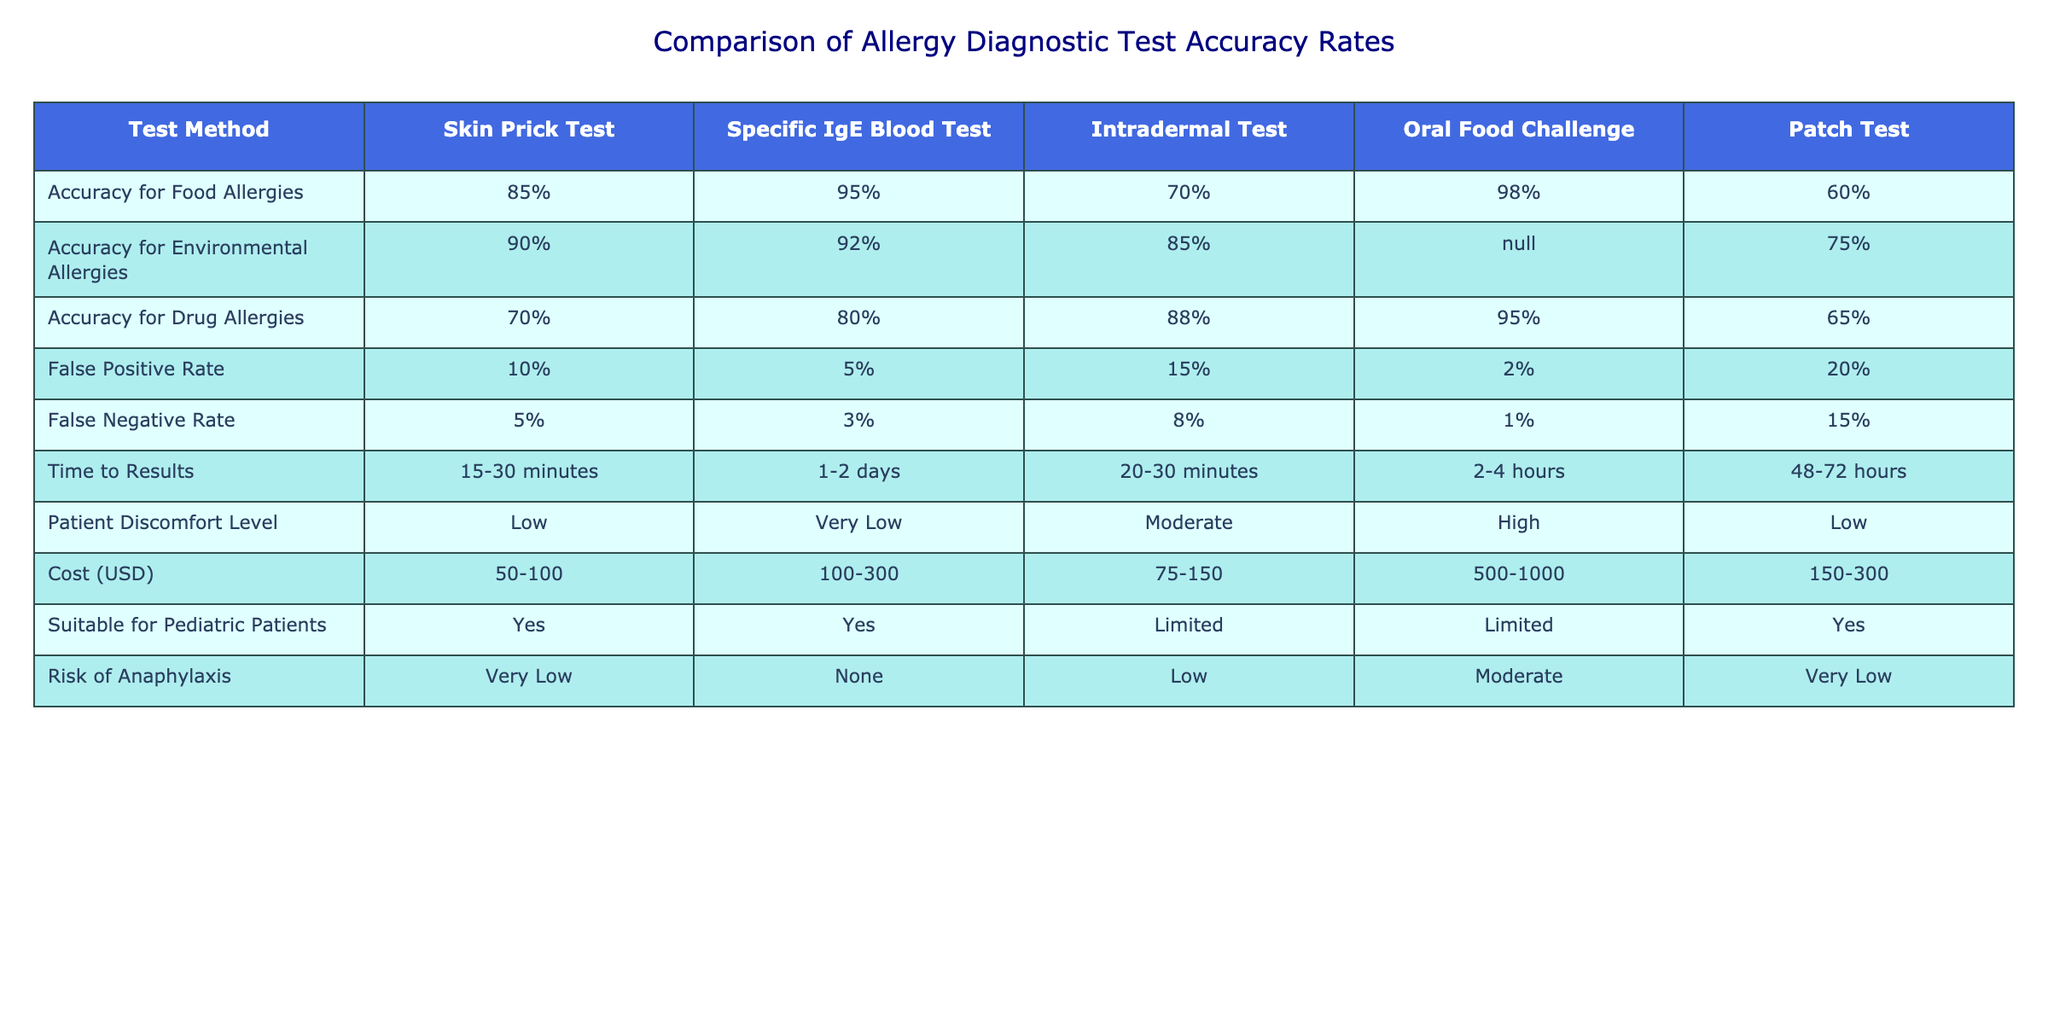What is the accuracy rate for food allergies using the Specific IgE Blood Test? The table shows that the accuracy rate for food allergies with the Specific IgE Blood Test is 95%.
Answer: 95% Which test has the highest false positive rate? The false positive rates for each test are listed, and the Patch Test has the highest rate at 20%.
Answer: Patch Test What is the false negative rate for the Oral Food Challenge? The table specifies that the false negative rate for the Oral Food Challenge is 1%.
Answer: 1% Is the Skin Prick Test suitable for pediatric patients? The table indicates that the Skin Prick Test is marked as "Yes" under suitable for pediatric patients.
Answer: Yes Which test has both a high accuracy rate for food allergies and a low risk of anaphylaxis? The Oral Food Challenge has an accuracy rate of 98% for food allergies and is classified as having a moderate risk of anaphylaxis, while both the Skin Prick Test and Specific IgE Blood Test have high accuracy rates with very low risk of anaphylaxis, but Specific IgE has a higher accuracy.
Answer: Specific IgE Blood Test What is the average cost of the Intradermal Test and the Patch Test? The costs are 75-150 USD for the Intradermal Test and 150-300 USD for the Patch Test. The average is ((75+150)/2 + (150+300)/2) = (112.5 + 225) / 2 = 168.75 USD.
Answer: 168.75 USD Among the tests, which one takes the longest to get results? Checking the time to results, the Patch Test has the longest time to results at 48-72 hours.
Answer: Patch Test What can you say about the patient discomfort levels for the tests? The Skin Prick Test and Patch Test have low discomfort levels, the Intradermal Test has moderate discomfort, while the Oral Food Challenge has high discomfort.
Answer: Varies from low to high Which test has the highest accuracy rate for environmental allergies? The table shows that the Skin Prick Test has the highest accuracy rate for environmental allergies at 90%.
Answer: Skin Prick Test What is the risk of anaphylaxis for the Specific IgE Blood Test? The table indicates that the Specific IgE Blood Test has no risk of anaphylaxis.
Answer: None Which allergy test has the highest accuracy for drug allergies? The accuracy for drug allergies is 95% for the Oral Food Challenge, which is the highest among the tests listed.
Answer: Oral Food Challenge 